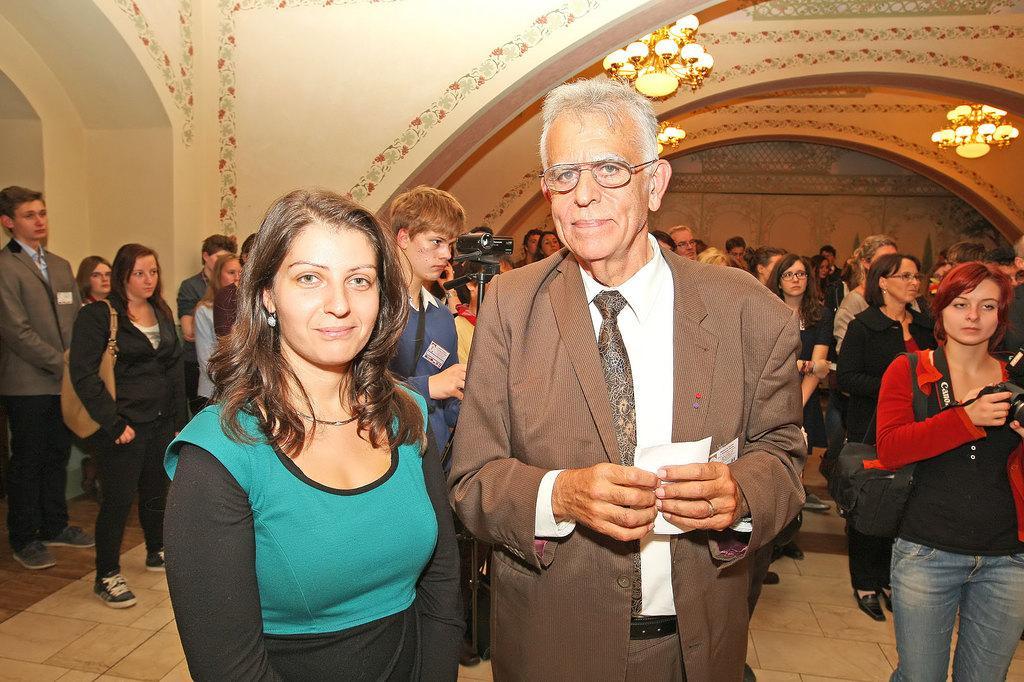In one or two sentences, can you explain what this image depicts? In this image in front there are two people wearing a smile on their faces. Behind them there are a few other people standing on the floor. In the background of the image there is a painting on the wall. On top of the image there are chandeliers. 